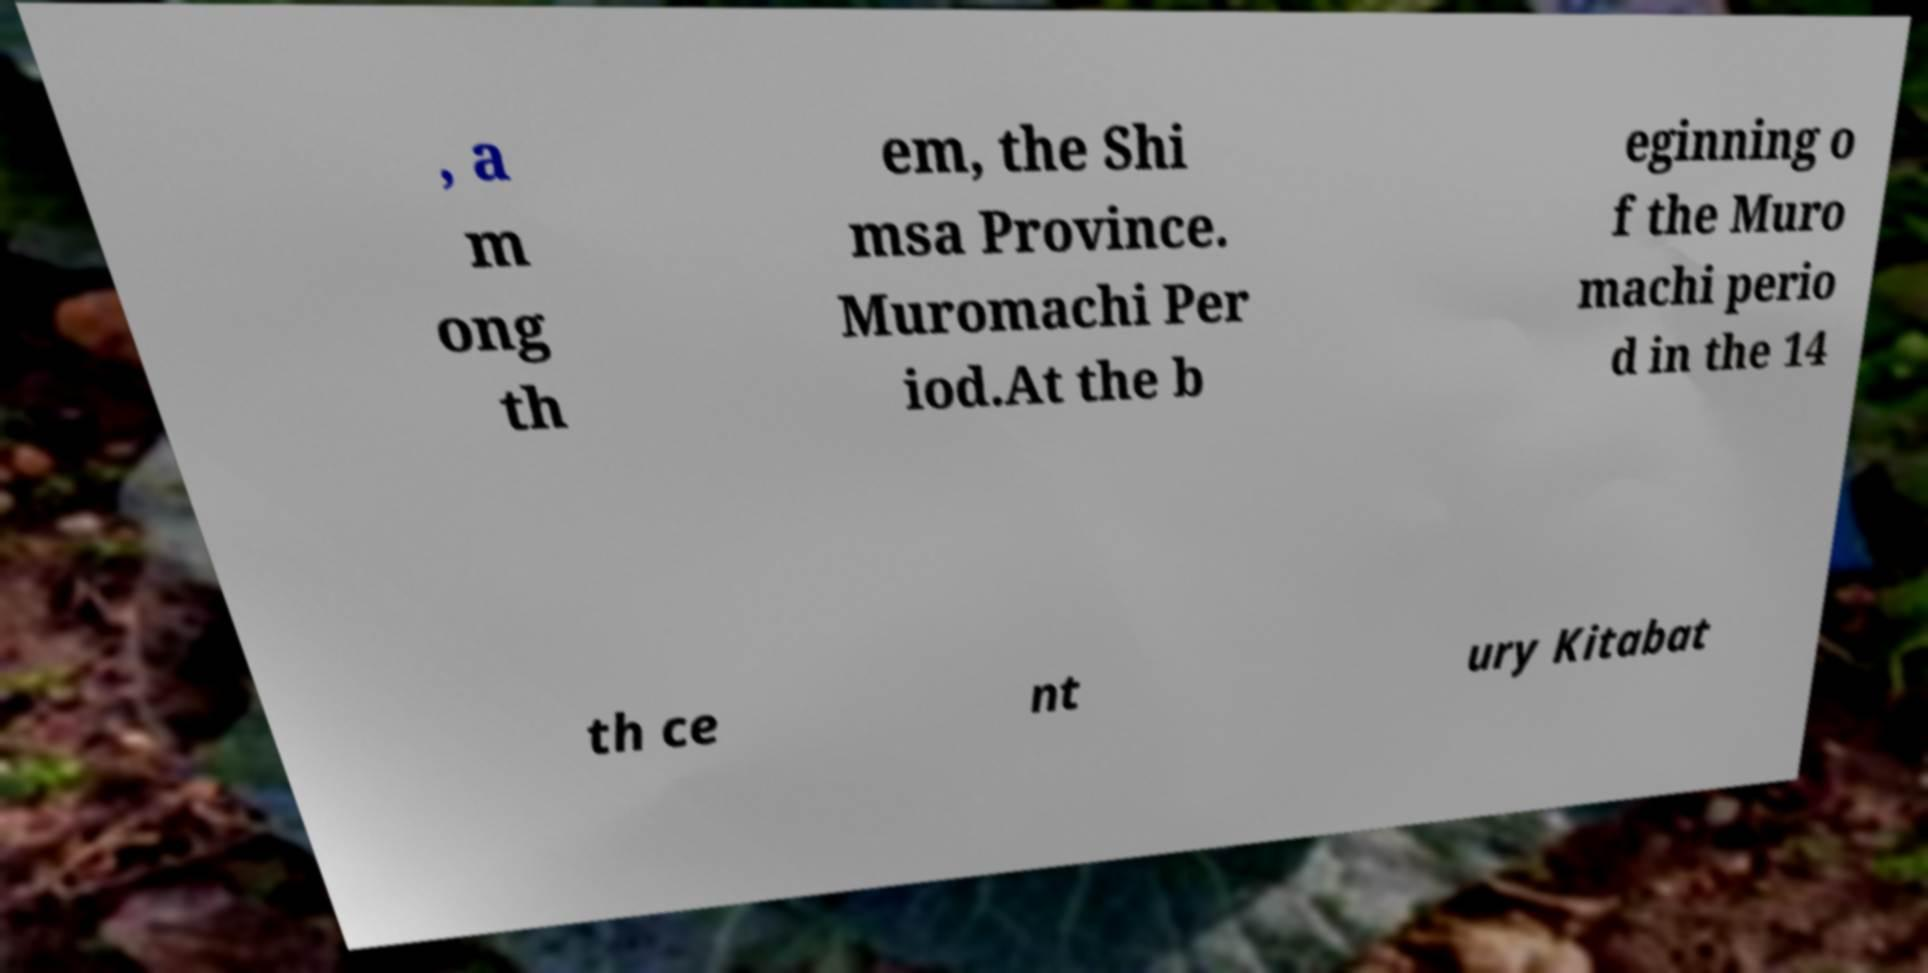Can you read and provide the text displayed in the image?This photo seems to have some interesting text. Can you extract and type it out for me? , a m ong th em, the Shi msa Province. Muromachi Per iod.At the b eginning o f the Muro machi perio d in the 14 th ce nt ury Kitabat 